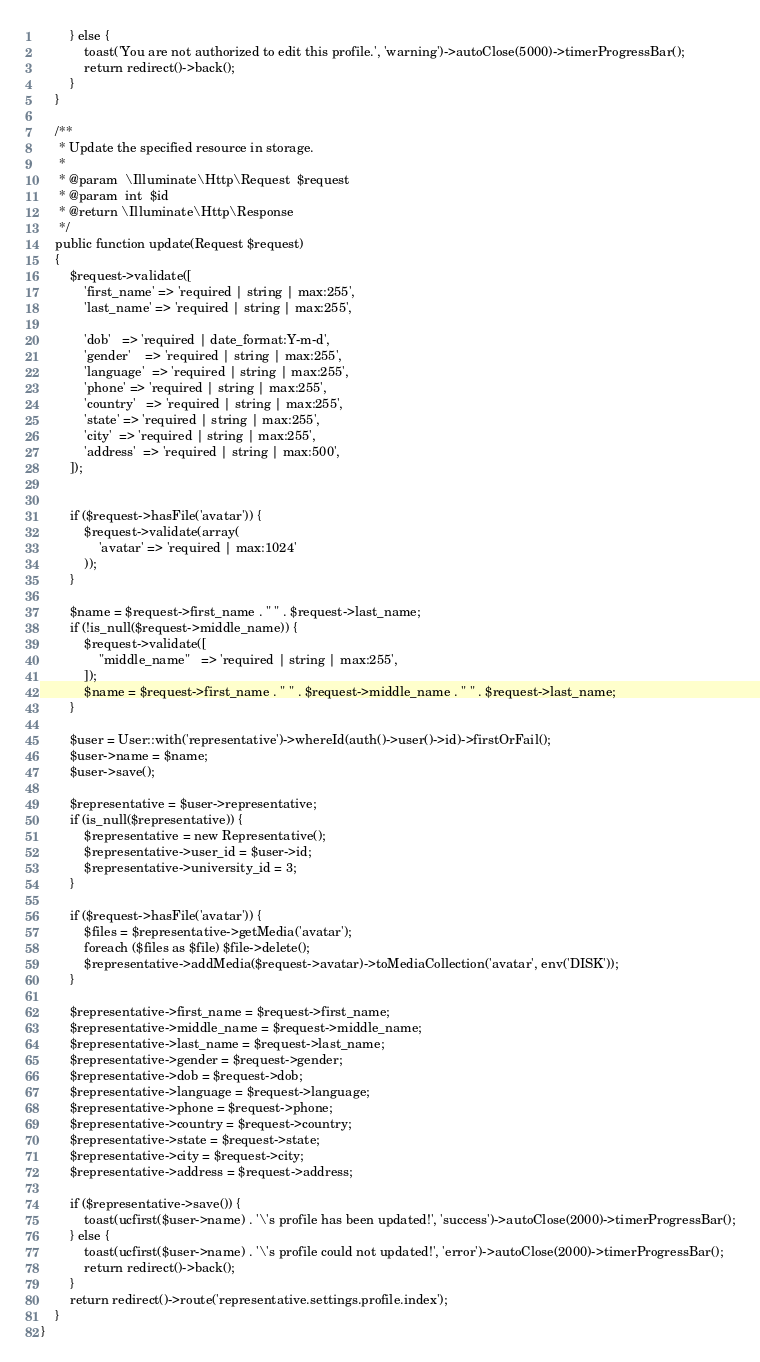<code> <loc_0><loc_0><loc_500><loc_500><_PHP_>        } else {
            toast('You are not authorized to edit this profile.', 'warning')->autoClose(5000)->timerProgressBar();
            return redirect()->back();
        }
    }

    /**
     * Update the specified resource in storage.
     *
     * @param  \Illuminate\Http\Request  $request
     * @param  int  $id
     * @return \Illuminate\Http\Response
     */
    public function update(Request $request)
    {
        $request->validate([
            'first_name' => 'required | string | max:255',
            'last_name' => 'required | string | max:255',

            'dob'   => 'required | date_format:Y-m-d',
            'gender'    => 'required | string | max:255',
            'language'  => 'required | string | max:255',
            'phone' => 'required | string | max:255',
            'country'   => 'required | string | max:255',
            'state' => 'required | string | max:255',
            'city'  => 'required | string | max:255',
            'address'  => 'required | string | max:500',
        ]);


        if ($request->hasFile('avatar')) {
            $request->validate(array(
                'avatar' => 'required | max:1024'
            ));
        }

        $name = $request->first_name . " " . $request->last_name;
        if (!is_null($request->middle_name)) {
            $request->validate([
                "middle_name"   => 'required | string | max:255',
            ]);
            $name = $request->first_name . " " . $request->middle_name . " " . $request->last_name;
        }

        $user = User::with('representative')->whereId(auth()->user()->id)->firstOrFail();
        $user->name = $name;
        $user->save();

        $representative = $user->representative;
        if (is_null($representative)) {
            $representative = new Representative();
            $representative->user_id = $user->id;
            $representative->university_id = 3;
        }

        if ($request->hasFile('avatar')) {
            $files = $representative->getMedia('avatar');
            foreach ($files as $file) $file->delete();
            $representative->addMedia($request->avatar)->toMediaCollection('avatar', env('DISK'));
        }

        $representative->first_name = $request->first_name;
        $representative->middle_name = $request->middle_name;
        $representative->last_name = $request->last_name;
        $representative->gender = $request->gender;
        $representative->dob = $request->dob;
        $representative->language = $request->language;
        $representative->phone = $request->phone;
        $representative->country = $request->country;
        $representative->state = $request->state;
        $representative->city = $request->city;
        $representative->address = $request->address;

        if ($representative->save()) {
            toast(ucfirst($user->name) . '\'s profile has been updated!', 'success')->autoClose(2000)->timerProgressBar();
        } else {
            toast(ucfirst($user->name) . '\'s profile could not updated!', 'error')->autoClose(2000)->timerProgressBar();
            return redirect()->back();
        }
        return redirect()->route('representative.settings.profile.index');
    }
}
</code> 